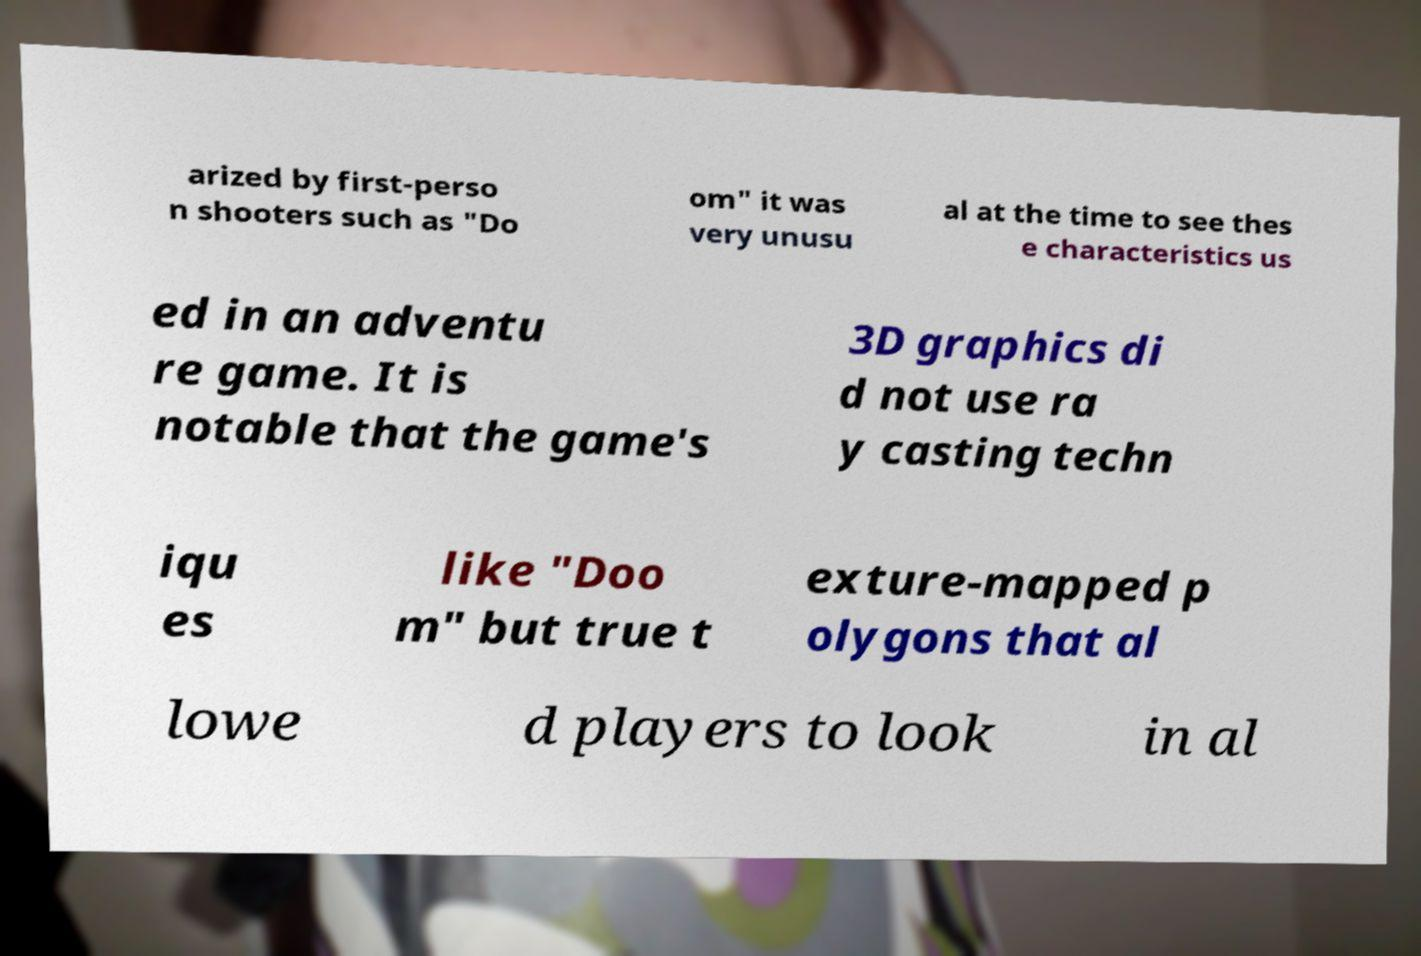Could you assist in decoding the text presented in this image and type it out clearly? arized by first-perso n shooters such as "Do om" it was very unusu al at the time to see thes e characteristics us ed in an adventu re game. It is notable that the game's 3D graphics di d not use ra y casting techn iqu es like "Doo m" but true t exture-mapped p olygons that al lowe d players to look in al 